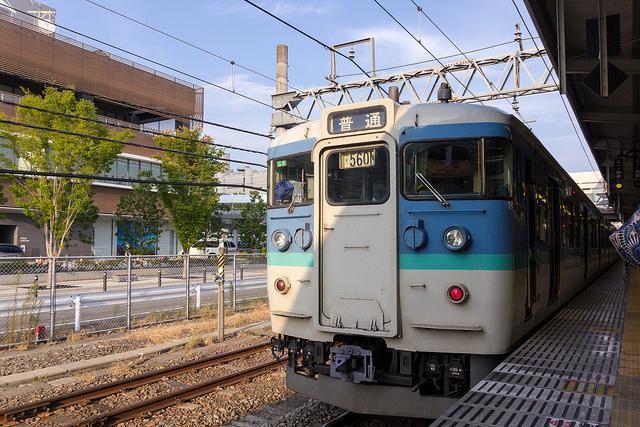How many blue frosted donuts can you count?
Give a very brief answer. 0. 